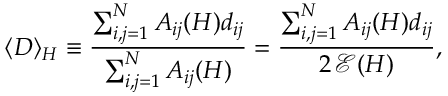Convert formula to latex. <formula><loc_0><loc_0><loc_500><loc_500>\langle D \rangle _ { H } \equiv \frac { \sum _ { i , j = 1 } ^ { N } A _ { i j } ( H ) d _ { i j } } { \sum _ { i , j = 1 } ^ { N } A _ { i j } ( H ) } = \frac { \sum _ { i , j = 1 } ^ { N } A _ { i j } ( H ) d _ { i j } } { 2 \, \mathcal { E } ( H ) } ,</formula> 